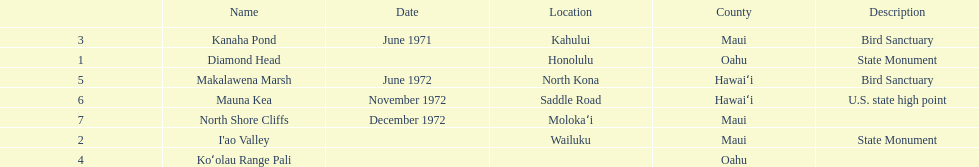How many names do not have a description? 2. 